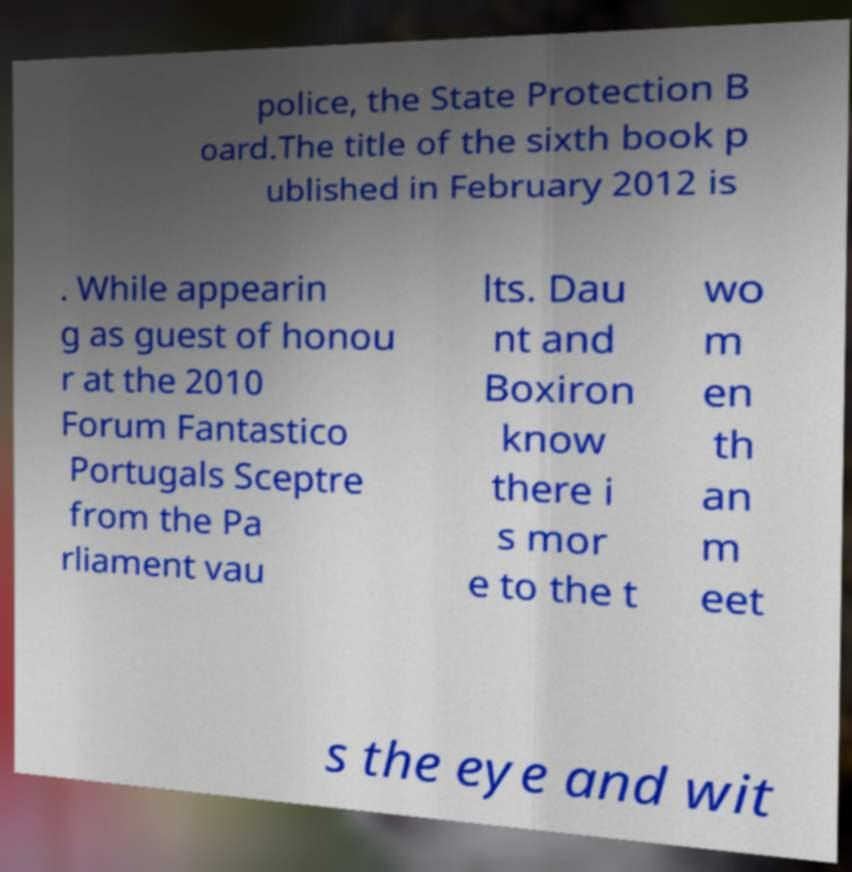Could you assist in decoding the text presented in this image and type it out clearly? police, the State Protection B oard.The title of the sixth book p ublished in February 2012 is . While appearin g as guest of honou r at the 2010 Forum Fantastico Portugals Sceptre from the Pa rliament vau lts. Dau nt and Boxiron know there i s mor e to the t wo m en th an m eet s the eye and wit 